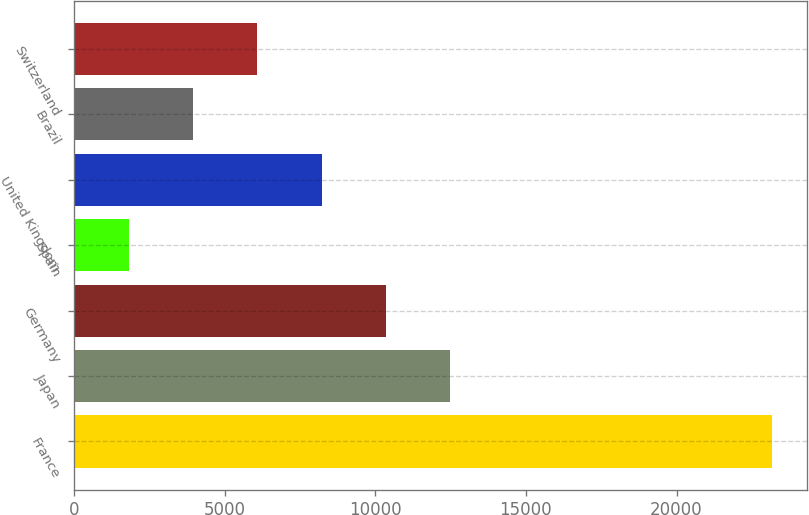Convert chart. <chart><loc_0><loc_0><loc_500><loc_500><bar_chart><fcel>France<fcel>Japan<fcel>Germany<fcel>Spain<fcel>United Kingdom<fcel>Brazil<fcel>Switzerland<nl><fcel>23161<fcel>12488.5<fcel>10354<fcel>1816<fcel>8219.5<fcel>3950.5<fcel>6085<nl></chart> 